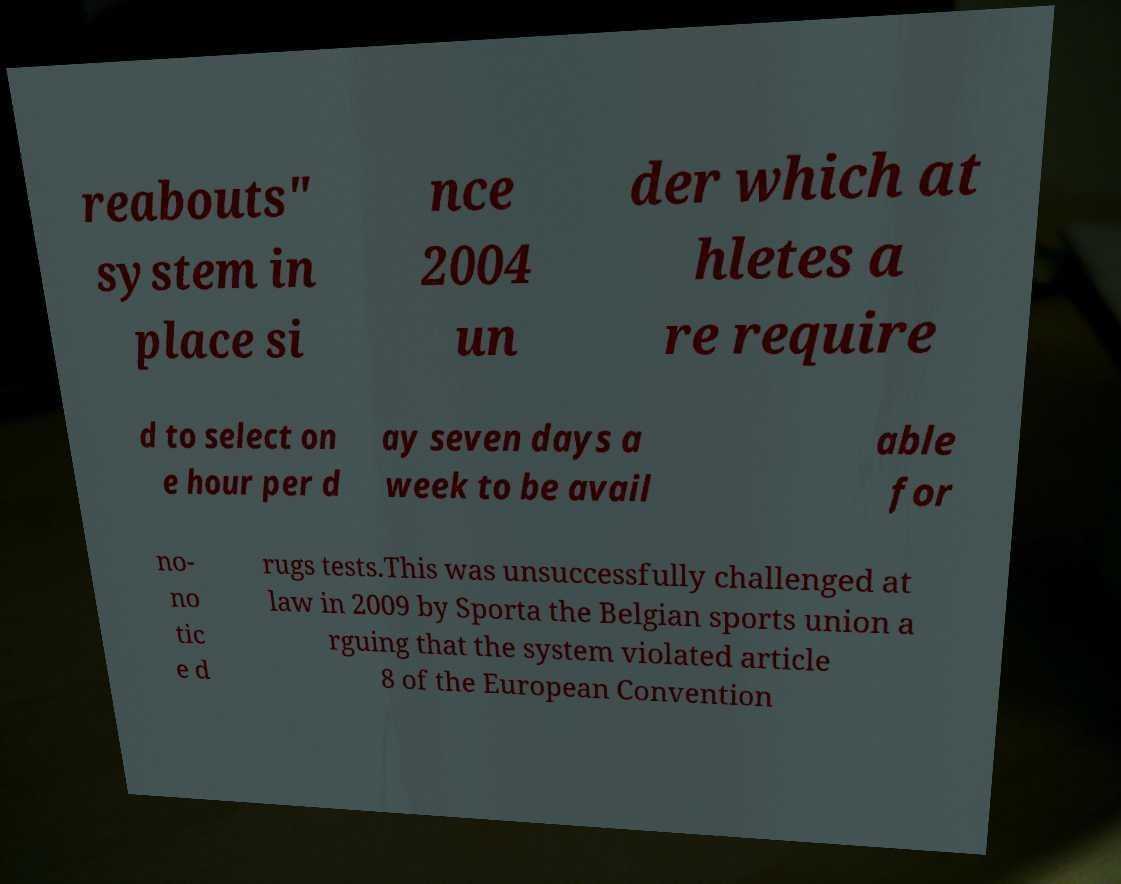Please read and relay the text visible in this image. What does it say? reabouts" system in place si nce 2004 un der which at hletes a re require d to select on e hour per d ay seven days a week to be avail able for no- no tic e d rugs tests.This was unsuccessfully challenged at law in 2009 by Sporta the Belgian sports union a rguing that the system violated article 8 of the European Convention 